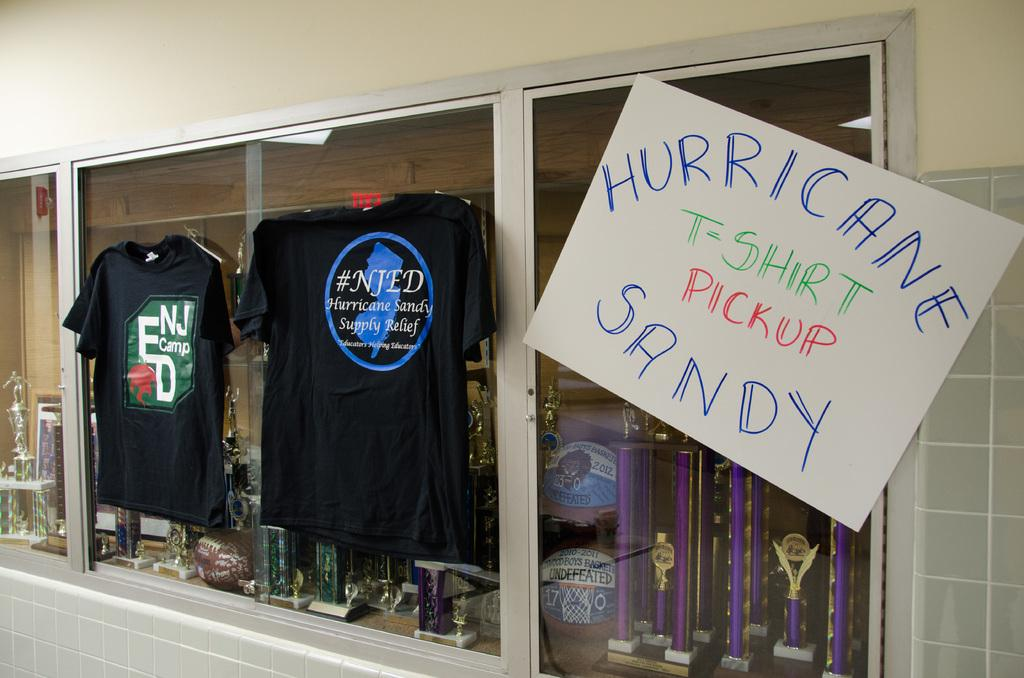<image>
Share a concise interpretation of the image provided. a shop with a hurricane sign in front of it 